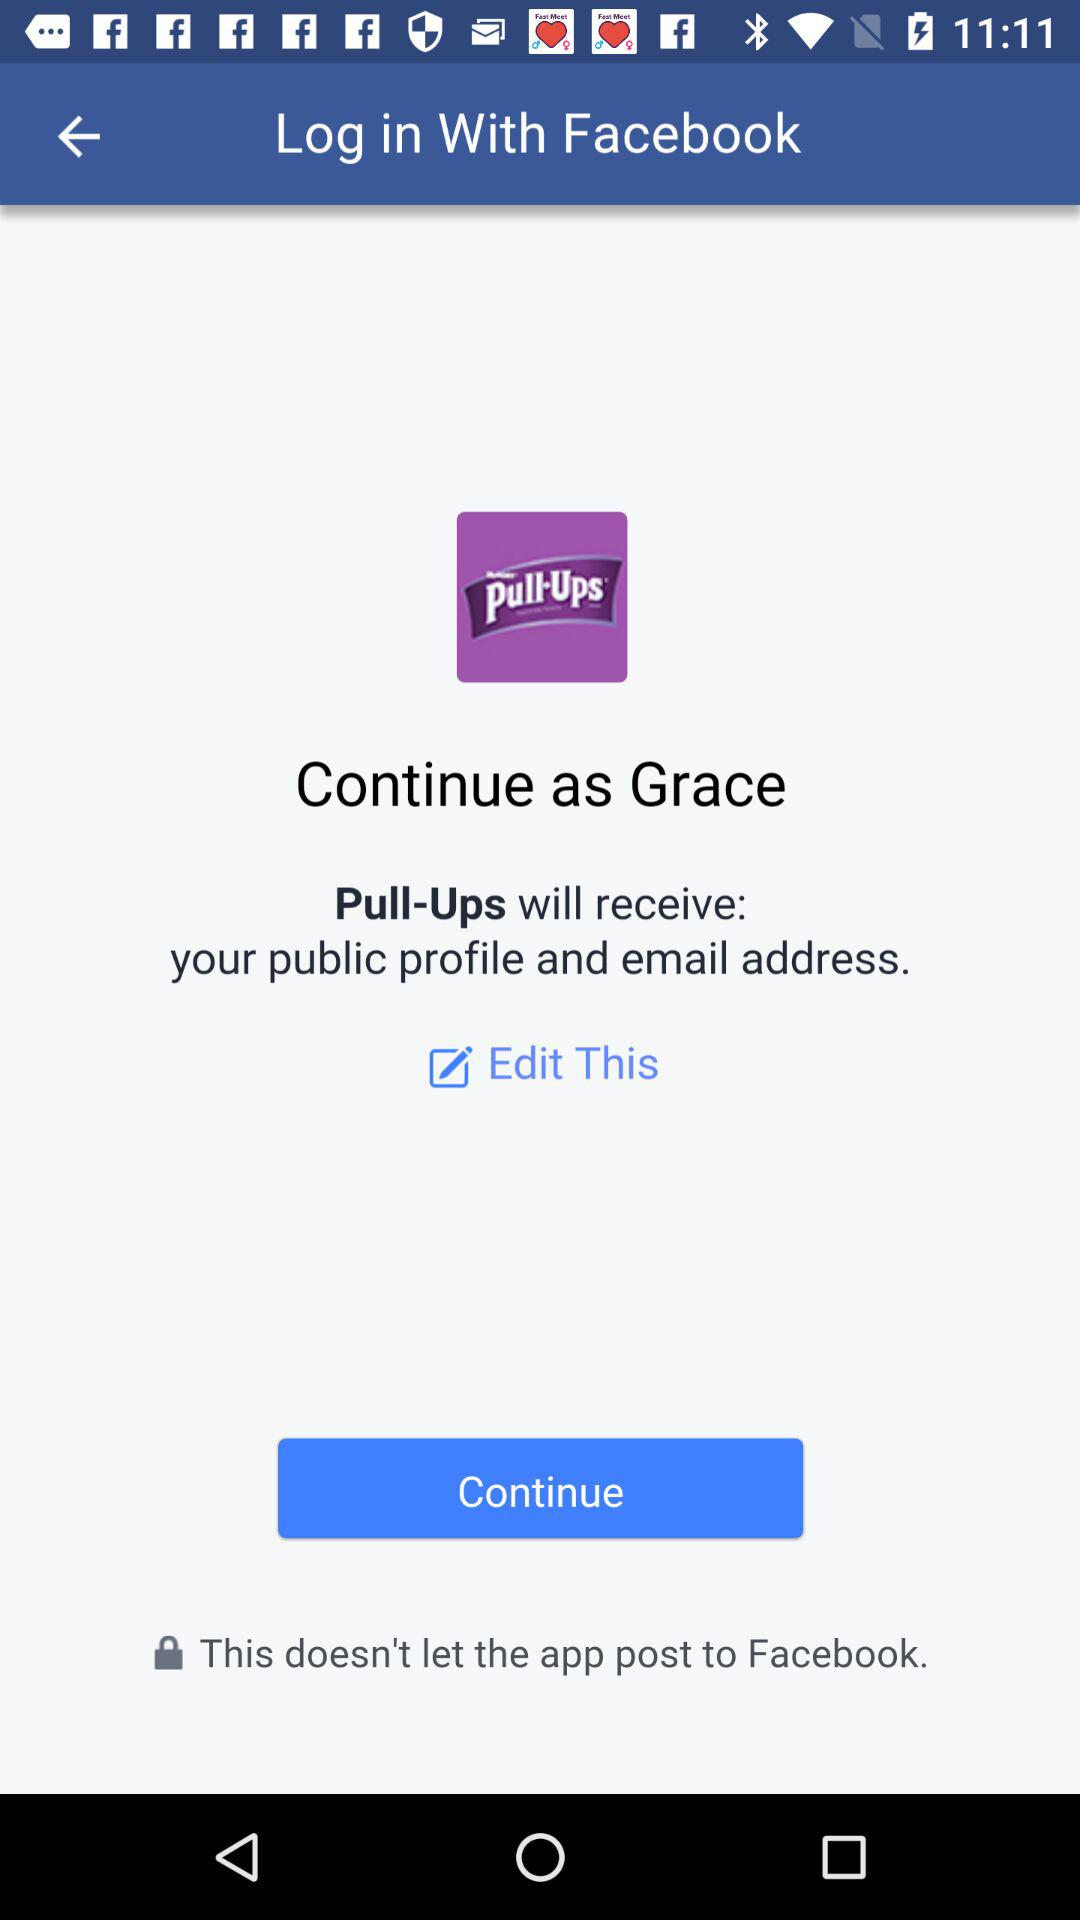What is the user name? The user name is Grace. 